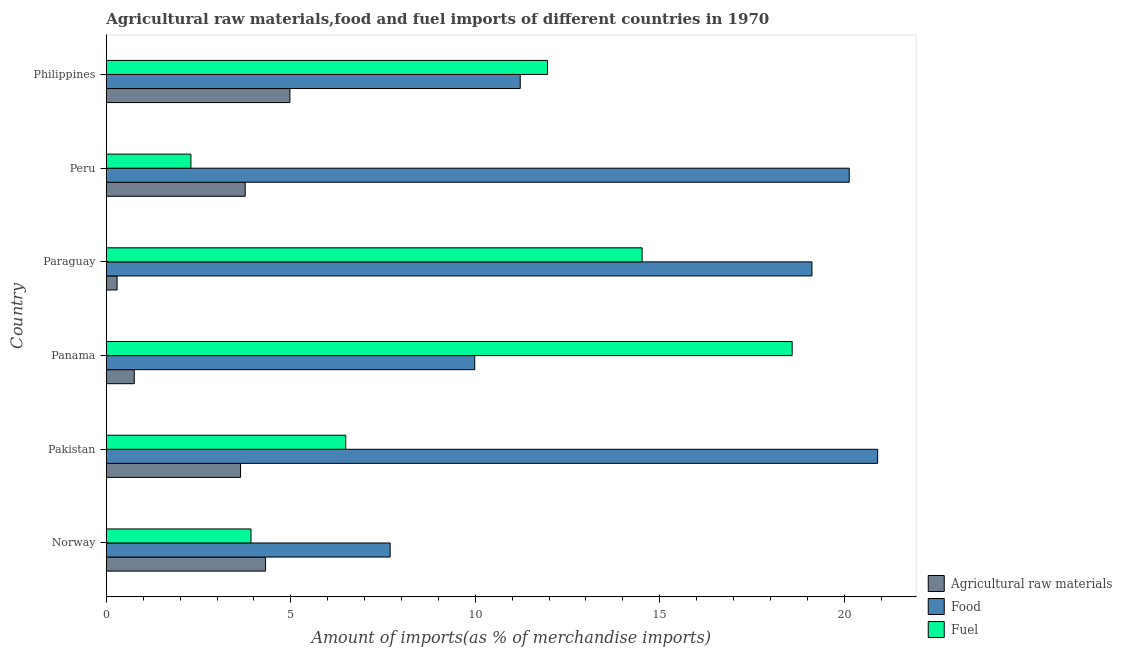Are the number of bars on each tick of the Y-axis equal?
Keep it short and to the point. Yes. In how many cases, is the number of bars for a given country not equal to the number of legend labels?
Ensure brevity in your answer.  0. What is the percentage of raw materials imports in Paraguay?
Provide a short and direct response. 0.29. Across all countries, what is the maximum percentage of food imports?
Your response must be concise. 20.91. Across all countries, what is the minimum percentage of fuel imports?
Ensure brevity in your answer.  2.29. What is the total percentage of raw materials imports in the graph?
Your answer should be compact. 17.74. What is the difference between the percentage of food imports in Norway and that in Pakistan?
Offer a terse response. -13.21. What is the difference between the percentage of raw materials imports in Panama and the percentage of fuel imports in Norway?
Make the answer very short. -3.16. What is the average percentage of raw materials imports per country?
Offer a terse response. 2.96. What is the difference between the percentage of food imports and percentage of raw materials imports in Panama?
Your answer should be very brief. 9.23. In how many countries, is the percentage of fuel imports greater than 16 %?
Ensure brevity in your answer.  1. What is the ratio of the percentage of fuel imports in Paraguay to that in Philippines?
Your answer should be very brief. 1.21. What is the difference between the highest and the second highest percentage of fuel imports?
Ensure brevity in your answer.  4.07. What is the difference between the highest and the lowest percentage of raw materials imports?
Ensure brevity in your answer.  4.69. In how many countries, is the percentage of food imports greater than the average percentage of food imports taken over all countries?
Ensure brevity in your answer.  3. Is the sum of the percentage of raw materials imports in Pakistan and Paraguay greater than the maximum percentage of fuel imports across all countries?
Your answer should be compact. No. What does the 3rd bar from the top in Pakistan represents?
Give a very brief answer. Agricultural raw materials. What does the 3rd bar from the bottom in Paraguay represents?
Offer a very short reply. Fuel. Is it the case that in every country, the sum of the percentage of raw materials imports and percentage of food imports is greater than the percentage of fuel imports?
Ensure brevity in your answer.  No. How many bars are there?
Provide a succinct answer. 18. Are all the bars in the graph horizontal?
Provide a succinct answer. Yes. How many countries are there in the graph?
Your answer should be very brief. 6. What is the difference between two consecutive major ticks on the X-axis?
Offer a terse response. 5. Are the values on the major ticks of X-axis written in scientific E-notation?
Make the answer very short. No. Does the graph contain any zero values?
Provide a short and direct response. No. Does the graph contain grids?
Keep it short and to the point. No. Where does the legend appear in the graph?
Give a very brief answer. Bottom right. How are the legend labels stacked?
Provide a succinct answer. Vertical. What is the title of the graph?
Make the answer very short. Agricultural raw materials,food and fuel imports of different countries in 1970. What is the label or title of the X-axis?
Your answer should be very brief. Amount of imports(as % of merchandise imports). What is the label or title of the Y-axis?
Your response must be concise. Country. What is the Amount of imports(as % of merchandise imports) in Agricultural raw materials in Norway?
Provide a short and direct response. 4.32. What is the Amount of imports(as % of merchandise imports) in Food in Norway?
Provide a succinct answer. 7.69. What is the Amount of imports(as % of merchandise imports) in Fuel in Norway?
Your answer should be compact. 3.92. What is the Amount of imports(as % of merchandise imports) of Agricultural raw materials in Pakistan?
Your answer should be very brief. 3.64. What is the Amount of imports(as % of merchandise imports) of Food in Pakistan?
Give a very brief answer. 20.91. What is the Amount of imports(as % of merchandise imports) in Fuel in Pakistan?
Your answer should be compact. 6.49. What is the Amount of imports(as % of merchandise imports) in Agricultural raw materials in Panama?
Provide a short and direct response. 0.76. What is the Amount of imports(as % of merchandise imports) in Food in Panama?
Keep it short and to the point. 9.99. What is the Amount of imports(as % of merchandise imports) in Fuel in Panama?
Give a very brief answer. 18.59. What is the Amount of imports(as % of merchandise imports) of Agricultural raw materials in Paraguay?
Your response must be concise. 0.29. What is the Amount of imports(as % of merchandise imports) in Food in Paraguay?
Give a very brief answer. 19.13. What is the Amount of imports(as % of merchandise imports) of Fuel in Paraguay?
Ensure brevity in your answer.  14.52. What is the Amount of imports(as % of merchandise imports) of Agricultural raw materials in Peru?
Your answer should be very brief. 3.76. What is the Amount of imports(as % of merchandise imports) in Food in Peru?
Provide a short and direct response. 20.14. What is the Amount of imports(as % of merchandise imports) in Fuel in Peru?
Keep it short and to the point. 2.29. What is the Amount of imports(as % of merchandise imports) in Agricultural raw materials in Philippines?
Offer a terse response. 4.98. What is the Amount of imports(as % of merchandise imports) of Food in Philippines?
Keep it short and to the point. 11.22. What is the Amount of imports(as % of merchandise imports) in Fuel in Philippines?
Keep it short and to the point. 11.96. Across all countries, what is the maximum Amount of imports(as % of merchandise imports) of Agricultural raw materials?
Offer a terse response. 4.98. Across all countries, what is the maximum Amount of imports(as % of merchandise imports) of Food?
Make the answer very short. 20.91. Across all countries, what is the maximum Amount of imports(as % of merchandise imports) in Fuel?
Provide a succinct answer. 18.59. Across all countries, what is the minimum Amount of imports(as % of merchandise imports) of Agricultural raw materials?
Give a very brief answer. 0.29. Across all countries, what is the minimum Amount of imports(as % of merchandise imports) of Food?
Ensure brevity in your answer.  7.69. Across all countries, what is the minimum Amount of imports(as % of merchandise imports) in Fuel?
Keep it short and to the point. 2.29. What is the total Amount of imports(as % of merchandise imports) of Agricultural raw materials in the graph?
Your response must be concise. 17.74. What is the total Amount of imports(as % of merchandise imports) in Food in the graph?
Offer a terse response. 89.08. What is the total Amount of imports(as % of merchandise imports) of Fuel in the graph?
Offer a terse response. 57.78. What is the difference between the Amount of imports(as % of merchandise imports) in Agricultural raw materials in Norway and that in Pakistan?
Keep it short and to the point. 0.68. What is the difference between the Amount of imports(as % of merchandise imports) in Food in Norway and that in Pakistan?
Make the answer very short. -13.21. What is the difference between the Amount of imports(as % of merchandise imports) in Fuel in Norway and that in Pakistan?
Provide a succinct answer. -2.57. What is the difference between the Amount of imports(as % of merchandise imports) of Agricultural raw materials in Norway and that in Panama?
Your answer should be compact. 3.56. What is the difference between the Amount of imports(as % of merchandise imports) of Food in Norway and that in Panama?
Your answer should be very brief. -2.29. What is the difference between the Amount of imports(as % of merchandise imports) in Fuel in Norway and that in Panama?
Provide a short and direct response. -14.67. What is the difference between the Amount of imports(as % of merchandise imports) in Agricultural raw materials in Norway and that in Paraguay?
Your response must be concise. 4.03. What is the difference between the Amount of imports(as % of merchandise imports) of Food in Norway and that in Paraguay?
Keep it short and to the point. -11.43. What is the difference between the Amount of imports(as % of merchandise imports) in Fuel in Norway and that in Paraguay?
Your answer should be compact. -10.6. What is the difference between the Amount of imports(as % of merchandise imports) of Agricultural raw materials in Norway and that in Peru?
Make the answer very short. 0.55. What is the difference between the Amount of imports(as % of merchandise imports) of Food in Norway and that in Peru?
Your answer should be very brief. -12.44. What is the difference between the Amount of imports(as % of merchandise imports) of Fuel in Norway and that in Peru?
Offer a terse response. 1.63. What is the difference between the Amount of imports(as % of merchandise imports) in Agricultural raw materials in Norway and that in Philippines?
Provide a short and direct response. -0.66. What is the difference between the Amount of imports(as % of merchandise imports) of Food in Norway and that in Philippines?
Provide a succinct answer. -3.53. What is the difference between the Amount of imports(as % of merchandise imports) of Fuel in Norway and that in Philippines?
Your answer should be compact. -8.04. What is the difference between the Amount of imports(as % of merchandise imports) in Agricultural raw materials in Pakistan and that in Panama?
Make the answer very short. 2.88. What is the difference between the Amount of imports(as % of merchandise imports) in Food in Pakistan and that in Panama?
Your answer should be compact. 10.92. What is the difference between the Amount of imports(as % of merchandise imports) in Fuel in Pakistan and that in Panama?
Offer a terse response. -12.1. What is the difference between the Amount of imports(as % of merchandise imports) of Agricultural raw materials in Pakistan and that in Paraguay?
Make the answer very short. 3.35. What is the difference between the Amount of imports(as % of merchandise imports) in Food in Pakistan and that in Paraguay?
Provide a succinct answer. 1.78. What is the difference between the Amount of imports(as % of merchandise imports) of Fuel in Pakistan and that in Paraguay?
Offer a very short reply. -8.03. What is the difference between the Amount of imports(as % of merchandise imports) of Agricultural raw materials in Pakistan and that in Peru?
Offer a terse response. -0.13. What is the difference between the Amount of imports(as % of merchandise imports) in Food in Pakistan and that in Peru?
Provide a short and direct response. 0.77. What is the difference between the Amount of imports(as % of merchandise imports) of Fuel in Pakistan and that in Peru?
Your answer should be very brief. 4.2. What is the difference between the Amount of imports(as % of merchandise imports) of Agricultural raw materials in Pakistan and that in Philippines?
Your answer should be very brief. -1.34. What is the difference between the Amount of imports(as % of merchandise imports) of Food in Pakistan and that in Philippines?
Keep it short and to the point. 9.69. What is the difference between the Amount of imports(as % of merchandise imports) of Fuel in Pakistan and that in Philippines?
Your answer should be very brief. -5.47. What is the difference between the Amount of imports(as % of merchandise imports) in Agricultural raw materials in Panama and that in Paraguay?
Give a very brief answer. 0.47. What is the difference between the Amount of imports(as % of merchandise imports) of Food in Panama and that in Paraguay?
Your response must be concise. -9.14. What is the difference between the Amount of imports(as % of merchandise imports) in Fuel in Panama and that in Paraguay?
Make the answer very short. 4.07. What is the difference between the Amount of imports(as % of merchandise imports) in Agricultural raw materials in Panama and that in Peru?
Offer a terse response. -3.01. What is the difference between the Amount of imports(as % of merchandise imports) in Food in Panama and that in Peru?
Offer a terse response. -10.15. What is the difference between the Amount of imports(as % of merchandise imports) of Fuel in Panama and that in Peru?
Your answer should be compact. 16.3. What is the difference between the Amount of imports(as % of merchandise imports) in Agricultural raw materials in Panama and that in Philippines?
Offer a very short reply. -4.22. What is the difference between the Amount of imports(as % of merchandise imports) in Food in Panama and that in Philippines?
Make the answer very short. -1.23. What is the difference between the Amount of imports(as % of merchandise imports) of Fuel in Panama and that in Philippines?
Your response must be concise. 6.63. What is the difference between the Amount of imports(as % of merchandise imports) of Agricultural raw materials in Paraguay and that in Peru?
Provide a succinct answer. -3.47. What is the difference between the Amount of imports(as % of merchandise imports) of Food in Paraguay and that in Peru?
Provide a short and direct response. -1.01. What is the difference between the Amount of imports(as % of merchandise imports) of Fuel in Paraguay and that in Peru?
Give a very brief answer. 12.23. What is the difference between the Amount of imports(as % of merchandise imports) of Agricultural raw materials in Paraguay and that in Philippines?
Keep it short and to the point. -4.69. What is the difference between the Amount of imports(as % of merchandise imports) in Food in Paraguay and that in Philippines?
Offer a terse response. 7.91. What is the difference between the Amount of imports(as % of merchandise imports) of Fuel in Paraguay and that in Philippines?
Provide a short and direct response. 2.56. What is the difference between the Amount of imports(as % of merchandise imports) of Agricultural raw materials in Peru and that in Philippines?
Provide a short and direct response. -1.21. What is the difference between the Amount of imports(as % of merchandise imports) of Food in Peru and that in Philippines?
Your answer should be very brief. 8.92. What is the difference between the Amount of imports(as % of merchandise imports) in Fuel in Peru and that in Philippines?
Your answer should be very brief. -9.67. What is the difference between the Amount of imports(as % of merchandise imports) in Agricultural raw materials in Norway and the Amount of imports(as % of merchandise imports) in Food in Pakistan?
Make the answer very short. -16.59. What is the difference between the Amount of imports(as % of merchandise imports) of Agricultural raw materials in Norway and the Amount of imports(as % of merchandise imports) of Fuel in Pakistan?
Your answer should be very brief. -2.17. What is the difference between the Amount of imports(as % of merchandise imports) of Food in Norway and the Amount of imports(as % of merchandise imports) of Fuel in Pakistan?
Your answer should be compact. 1.2. What is the difference between the Amount of imports(as % of merchandise imports) in Agricultural raw materials in Norway and the Amount of imports(as % of merchandise imports) in Food in Panama?
Provide a succinct answer. -5.67. What is the difference between the Amount of imports(as % of merchandise imports) in Agricultural raw materials in Norway and the Amount of imports(as % of merchandise imports) in Fuel in Panama?
Make the answer very short. -14.28. What is the difference between the Amount of imports(as % of merchandise imports) in Food in Norway and the Amount of imports(as % of merchandise imports) in Fuel in Panama?
Make the answer very short. -10.9. What is the difference between the Amount of imports(as % of merchandise imports) in Agricultural raw materials in Norway and the Amount of imports(as % of merchandise imports) in Food in Paraguay?
Keep it short and to the point. -14.81. What is the difference between the Amount of imports(as % of merchandise imports) in Agricultural raw materials in Norway and the Amount of imports(as % of merchandise imports) in Fuel in Paraguay?
Provide a succinct answer. -10.21. What is the difference between the Amount of imports(as % of merchandise imports) of Food in Norway and the Amount of imports(as % of merchandise imports) of Fuel in Paraguay?
Your answer should be very brief. -6.83. What is the difference between the Amount of imports(as % of merchandise imports) of Agricultural raw materials in Norway and the Amount of imports(as % of merchandise imports) of Food in Peru?
Provide a short and direct response. -15.82. What is the difference between the Amount of imports(as % of merchandise imports) of Agricultural raw materials in Norway and the Amount of imports(as % of merchandise imports) of Fuel in Peru?
Your response must be concise. 2.02. What is the difference between the Amount of imports(as % of merchandise imports) in Food in Norway and the Amount of imports(as % of merchandise imports) in Fuel in Peru?
Ensure brevity in your answer.  5.4. What is the difference between the Amount of imports(as % of merchandise imports) of Agricultural raw materials in Norway and the Amount of imports(as % of merchandise imports) of Food in Philippines?
Keep it short and to the point. -6.9. What is the difference between the Amount of imports(as % of merchandise imports) in Agricultural raw materials in Norway and the Amount of imports(as % of merchandise imports) in Fuel in Philippines?
Your response must be concise. -7.64. What is the difference between the Amount of imports(as % of merchandise imports) in Food in Norway and the Amount of imports(as % of merchandise imports) in Fuel in Philippines?
Provide a short and direct response. -4.26. What is the difference between the Amount of imports(as % of merchandise imports) in Agricultural raw materials in Pakistan and the Amount of imports(as % of merchandise imports) in Food in Panama?
Provide a succinct answer. -6.35. What is the difference between the Amount of imports(as % of merchandise imports) in Agricultural raw materials in Pakistan and the Amount of imports(as % of merchandise imports) in Fuel in Panama?
Provide a short and direct response. -14.95. What is the difference between the Amount of imports(as % of merchandise imports) in Food in Pakistan and the Amount of imports(as % of merchandise imports) in Fuel in Panama?
Keep it short and to the point. 2.32. What is the difference between the Amount of imports(as % of merchandise imports) in Agricultural raw materials in Pakistan and the Amount of imports(as % of merchandise imports) in Food in Paraguay?
Offer a terse response. -15.49. What is the difference between the Amount of imports(as % of merchandise imports) in Agricultural raw materials in Pakistan and the Amount of imports(as % of merchandise imports) in Fuel in Paraguay?
Offer a terse response. -10.89. What is the difference between the Amount of imports(as % of merchandise imports) in Food in Pakistan and the Amount of imports(as % of merchandise imports) in Fuel in Paraguay?
Make the answer very short. 6.38. What is the difference between the Amount of imports(as % of merchandise imports) in Agricultural raw materials in Pakistan and the Amount of imports(as % of merchandise imports) in Food in Peru?
Provide a succinct answer. -16.5. What is the difference between the Amount of imports(as % of merchandise imports) in Agricultural raw materials in Pakistan and the Amount of imports(as % of merchandise imports) in Fuel in Peru?
Keep it short and to the point. 1.35. What is the difference between the Amount of imports(as % of merchandise imports) of Food in Pakistan and the Amount of imports(as % of merchandise imports) of Fuel in Peru?
Make the answer very short. 18.62. What is the difference between the Amount of imports(as % of merchandise imports) of Agricultural raw materials in Pakistan and the Amount of imports(as % of merchandise imports) of Food in Philippines?
Your response must be concise. -7.58. What is the difference between the Amount of imports(as % of merchandise imports) in Agricultural raw materials in Pakistan and the Amount of imports(as % of merchandise imports) in Fuel in Philippines?
Your answer should be very brief. -8.32. What is the difference between the Amount of imports(as % of merchandise imports) of Food in Pakistan and the Amount of imports(as % of merchandise imports) of Fuel in Philippines?
Offer a terse response. 8.95. What is the difference between the Amount of imports(as % of merchandise imports) in Agricultural raw materials in Panama and the Amount of imports(as % of merchandise imports) in Food in Paraguay?
Offer a very short reply. -18.37. What is the difference between the Amount of imports(as % of merchandise imports) in Agricultural raw materials in Panama and the Amount of imports(as % of merchandise imports) in Fuel in Paraguay?
Make the answer very short. -13.77. What is the difference between the Amount of imports(as % of merchandise imports) of Food in Panama and the Amount of imports(as % of merchandise imports) of Fuel in Paraguay?
Your answer should be very brief. -4.54. What is the difference between the Amount of imports(as % of merchandise imports) of Agricultural raw materials in Panama and the Amount of imports(as % of merchandise imports) of Food in Peru?
Your answer should be compact. -19.38. What is the difference between the Amount of imports(as % of merchandise imports) in Agricultural raw materials in Panama and the Amount of imports(as % of merchandise imports) in Fuel in Peru?
Offer a very short reply. -1.54. What is the difference between the Amount of imports(as % of merchandise imports) of Food in Panama and the Amount of imports(as % of merchandise imports) of Fuel in Peru?
Keep it short and to the point. 7.69. What is the difference between the Amount of imports(as % of merchandise imports) in Agricultural raw materials in Panama and the Amount of imports(as % of merchandise imports) in Food in Philippines?
Offer a very short reply. -10.46. What is the difference between the Amount of imports(as % of merchandise imports) in Agricultural raw materials in Panama and the Amount of imports(as % of merchandise imports) in Fuel in Philippines?
Keep it short and to the point. -11.2. What is the difference between the Amount of imports(as % of merchandise imports) of Food in Panama and the Amount of imports(as % of merchandise imports) of Fuel in Philippines?
Give a very brief answer. -1.97. What is the difference between the Amount of imports(as % of merchandise imports) in Agricultural raw materials in Paraguay and the Amount of imports(as % of merchandise imports) in Food in Peru?
Keep it short and to the point. -19.85. What is the difference between the Amount of imports(as % of merchandise imports) in Agricultural raw materials in Paraguay and the Amount of imports(as % of merchandise imports) in Fuel in Peru?
Your response must be concise. -2. What is the difference between the Amount of imports(as % of merchandise imports) of Food in Paraguay and the Amount of imports(as % of merchandise imports) of Fuel in Peru?
Your response must be concise. 16.83. What is the difference between the Amount of imports(as % of merchandise imports) of Agricultural raw materials in Paraguay and the Amount of imports(as % of merchandise imports) of Food in Philippines?
Make the answer very short. -10.93. What is the difference between the Amount of imports(as % of merchandise imports) of Agricultural raw materials in Paraguay and the Amount of imports(as % of merchandise imports) of Fuel in Philippines?
Provide a short and direct response. -11.67. What is the difference between the Amount of imports(as % of merchandise imports) in Food in Paraguay and the Amount of imports(as % of merchandise imports) in Fuel in Philippines?
Your answer should be compact. 7.17. What is the difference between the Amount of imports(as % of merchandise imports) of Agricultural raw materials in Peru and the Amount of imports(as % of merchandise imports) of Food in Philippines?
Provide a succinct answer. -7.46. What is the difference between the Amount of imports(as % of merchandise imports) in Agricultural raw materials in Peru and the Amount of imports(as % of merchandise imports) in Fuel in Philippines?
Your answer should be very brief. -8.19. What is the difference between the Amount of imports(as % of merchandise imports) of Food in Peru and the Amount of imports(as % of merchandise imports) of Fuel in Philippines?
Provide a succinct answer. 8.18. What is the average Amount of imports(as % of merchandise imports) of Agricultural raw materials per country?
Your response must be concise. 2.96. What is the average Amount of imports(as % of merchandise imports) of Food per country?
Provide a succinct answer. 14.85. What is the average Amount of imports(as % of merchandise imports) in Fuel per country?
Give a very brief answer. 9.63. What is the difference between the Amount of imports(as % of merchandise imports) in Agricultural raw materials and Amount of imports(as % of merchandise imports) in Food in Norway?
Offer a very short reply. -3.38. What is the difference between the Amount of imports(as % of merchandise imports) in Agricultural raw materials and Amount of imports(as % of merchandise imports) in Fuel in Norway?
Provide a succinct answer. 0.39. What is the difference between the Amount of imports(as % of merchandise imports) of Food and Amount of imports(as % of merchandise imports) of Fuel in Norway?
Give a very brief answer. 3.77. What is the difference between the Amount of imports(as % of merchandise imports) of Agricultural raw materials and Amount of imports(as % of merchandise imports) of Food in Pakistan?
Keep it short and to the point. -17.27. What is the difference between the Amount of imports(as % of merchandise imports) of Agricultural raw materials and Amount of imports(as % of merchandise imports) of Fuel in Pakistan?
Make the answer very short. -2.85. What is the difference between the Amount of imports(as % of merchandise imports) in Food and Amount of imports(as % of merchandise imports) in Fuel in Pakistan?
Provide a short and direct response. 14.42. What is the difference between the Amount of imports(as % of merchandise imports) of Agricultural raw materials and Amount of imports(as % of merchandise imports) of Food in Panama?
Offer a terse response. -9.23. What is the difference between the Amount of imports(as % of merchandise imports) in Agricultural raw materials and Amount of imports(as % of merchandise imports) in Fuel in Panama?
Make the answer very short. -17.83. What is the difference between the Amount of imports(as % of merchandise imports) of Food and Amount of imports(as % of merchandise imports) of Fuel in Panama?
Offer a very short reply. -8.6. What is the difference between the Amount of imports(as % of merchandise imports) of Agricultural raw materials and Amount of imports(as % of merchandise imports) of Food in Paraguay?
Offer a terse response. -18.84. What is the difference between the Amount of imports(as % of merchandise imports) in Agricultural raw materials and Amount of imports(as % of merchandise imports) in Fuel in Paraguay?
Your response must be concise. -14.23. What is the difference between the Amount of imports(as % of merchandise imports) in Food and Amount of imports(as % of merchandise imports) in Fuel in Paraguay?
Your answer should be compact. 4.6. What is the difference between the Amount of imports(as % of merchandise imports) in Agricultural raw materials and Amount of imports(as % of merchandise imports) in Food in Peru?
Provide a succinct answer. -16.37. What is the difference between the Amount of imports(as % of merchandise imports) in Agricultural raw materials and Amount of imports(as % of merchandise imports) in Fuel in Peru?
Give a very brief answer. 1.47. What is the difference between the Amount of imports(as % of merchandise imports) of Food and Amount of imports(as % of merchandise imports) of Fuel in Peru?
Provide a succinct answer. 17.85. What is the difference between the Amount of imports(as % of merchandise imports) in Agricultural raw materials and Amount of imports(as % of merchandise imports) in Food in Philippines?
Give a very brief answer. -6.24. What is the difference between the Amount of imports(as % of merchandise imports) in Agricultural raw materials and Amount of imports(as % of merchandise imports) in Fuel in Philippines?
Your answer should be very brief. -6.98. What is the difference between the Amount of imports(as % of merchandise imports) of Food and Amount of imports(as % of merchandise imports) of Fuel in Philippines?
Your response must be concise. -0.74. What is the ratio of the Amount of imports(as % of merchandise imports) of Agricultural raw materials in Norway to that in Pakistan?
Offer a very short reply. 1.19. What is the ratio of the Amount of imports(as % of merchandise imports) of Food in Norway to that in Pakistan?
Keep it short and to the point. 0.37. What is the ratio of the Amount of imports(as % of merchandise imports) in Fuel in Norway to that in Pakistan?
Your response must be concise. 0.6. What is the ratio of the Amount of imports(as % of merchandise imports) in Agricultural raw materials in Norway to that in Panama?
Ensure brevity in your answer.  5.7. What is the ratio of the Amount of imports(as % of merchandise imports) in Food in Norway to that in Panama?
Provide a short and direct response. 0.77. What is the ratio of the Amount of imports(as % of merchandise imports) in Fuel in Norway to that in Panama?
Give a very brief answer. 0.21. What is the ratio of the Amount of imports(as % of merchandise imports) in Agricultural raw materials in Norway to that in Paraguay?
Provide a succinct answer. 14.84. What is the ratio of the Amount of imports(as % of merchandise imports) in Food in Norway to that in Paraguay?
Your response must be concise. 0.4. What is the ratio of the Amount of imports(as % of merchandise imports) in Fuel in Norway to that in Paraguay?
Offer a terse response. 0.27. What is the ratio of the Amount of imports(as % of merchandise imports) of Agricultural raw materials in Norway to that in Peru?
Your response must be concise. 1.15. What is the ratio of the Amount of imports(as % of merchandise imports) of Food in Norway to that in Peru?
Offer a terse response. 0.38. What is the ratio of the Amount of imports(as % of merchandise imports) in Fuel in Norway to that in Peru?
Provide a succinct answer. 1.71. What is the ratio of the Amount of imports(as % of merchandise imports) of Agricultural raw materials in Norway to that in Philippines?
Your answer should be compact. 0.87. What is the ratio of the Amount of imports(as % of merchandise imports) in Food in Norway to that in Philippines?
Your answer should be very brief. 0.69. What is the ratio of the Amount of imports(as % of merchandise imports) of Fuel in Norway to that in Philippines?
Offer a very short reply. 0.33. What is the ratio of the Amount of imports(as % of merchandise imports) of Agricultural raw materials in Pakistan to that in Panama?
Your answer should be compact. 4.81. What is the ratio of the Amount of imports(as % of merchandise imports) of Food in Pakistan to that in Panama?
Give a very brief answer. 2.09. What is the ratio of the Amount of imports(as % of merchandise imports) in Fuel in Pakistan to that in Panama?
Your answer should be very brief. 0.35. What is the ratio of the Amount of imports(as % of merchandise imports) in Agricultural raw materials in Pakistan to that in Paraguay?
Provide a succinct answer. 12.51. What is the ratio of the Amount of imports(as % of merchandise imports) in Food in Pakistan to that in Paraguay?
Ensure brevity in your answer.  1.09. What is the ratio of the Amount of imports(as % of merchandise imports) in Fuel in Pakistan to that in Paraguay?
Offer a very short reply. 0.45. What is the ratio of the Amount of imports(as % of merchandise imports) of Agricultural raw materials in Pakistan to that in Peru?
Give a very brief answer. 0.97. What is the ratio of the Amount of imports(as % of merchandise imports) in Food in Pakistan to that in Peru?
Offer a very short reply. 1.04. What is the ratio of the Amount of imports(as % of merchandise imports) of Fuel in Pakistan to that in Peru?
Provide a succinct answer. 2.83. What is the ratio of the Amount of imports(as % of merchandise imports) of Agricultural raw materials in Pakistan to that in Philippines?
Ensure brevity in your answer.  0.73. What is the ratio of the Amount of imports(as % of merchandise imports) in Food in Pakistan to that in Philippines?
Ensure brevity in your answer.  1.86. What is the ratio of the Amount of imports(as % of merchandise imports) of Fuel in Pakistan to that in Philippines?
Provide a short and direct response. 0.54. What is the ratio of the Amount of imports(as % of merchandise imports) in Agricultural raw materials in Panama to that in Paraguay?
Your answer should be very brief. 2.6. What is the ratio of the Amount of imports(as % of merchandise imports) of Food in Panama to that in Paraguay?
Offer a very short reply. 0.52. What is the ratio of the Amount of imports(as % of merchandise imports) in Fuel in Panama to that in Paraguay?
Offer a terse response. 1.28. What is the ratio of the Amount of imports(as % of merchandise imports) in Agricultural raw materials in Panama to that in Peru?
Your response must be concise. 0.2. What is the ratio of the Amount of imports(as % of merchandise imports) of Food in Panama to that in Peru?
Your response must be concise. 0.5. What is the ratio of the Amount of imports(as % of merchandise imports) of Fuel in Panama to that in Peru?
Give a very brief answer. 8.11. What is the ratio of the Amount of imports(as % of merchandise imports) of Agricultural raw materials in Panama to that in Philippines?
Your response must be concise. 0.15. What is the ratio of the Amount of imports(as % of merchandise imports) of Food in Panama to that in Philippines?
Your answer should be very brief. 0.89. What is the ratio of the Amount of imports(as % of merchandise imports) in Fuel in Panama to that in Philippines?
Ensure brevity in your answer.  1.55. What is the ratio of the Amount of imports(as % of merchandise imports) of Agricultural raw materials in Paraguay to that in Peru?
Your response must be concise. 0.08. What is the ratio of the Amount of imports(as % of merchandise imports) of Food in Paraguay to that in Peru?
Provide a short and direct response. 0.95. What is the ratio of the Amount of imports(as % of merchandise imports) of Fuel in Paraguay to that in Peru?
Make the answer very short. 6.33. What is the ratio of the Amount of imports(as % of merchandise imports) in Agricultural raw materials in Paraguay to that in Philippines?
Give a very brief answer. 0.06. What is the ratio of the Amount of imports(as % of merchandise imports) in Food in Paraguay to that in Philippines?
Keep it short and to the point. 1.7. What is the ratio of the Amount of imports(as % of merchandise imports) in Fuel in Paraguay to that in Philippines?
Keep it short and to the point. 1.21. What is the ratio of the Amount of imports(as % of merchandise imports) in Agricultural raw materials in Peru to that in Philippines?
Give a very brief answer. 0.76. What is the ratio of the Amount of imports(as % of merchandise imports) of Food in Peru to that in Philippines?
Offer a very short reply. 1.79. What is the ratio of the Amount of imports(as % of merchandise imports) in Fuel in Peru to that in Philippines?
Ensure brevity in your answer.  0.19. What is the difference between the highest and the second highest Amount of imports(as % of merchandise imports) of Agricultural raw materials?
Provide a short and direct response. 0.66. What is the difference between the highest and the second highest Amount of imports(as % of merchandise imports) in Food?
Provide a short and direct response. 0.77. What is the difference between the highest and the second highest Amount of imports(as % of merchandise imports) in Fuel?
Your answer should be very brief. 4.07. What is the difference between the highest and the lowest Amount of imports(as % of merchandise imports) of Agricultural raw materials?
Keep it short and to the point. 4.69. What is the difference between the highest and the lowest Amount of imports(as % of merchandise imports) of Food?
Provide a succinct answer. 13.21. What is the difference between the highest and the lowest Amount of imports(as % of merchandise imports) in Fuel?
Offer a very short reply. 16.3. 